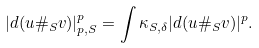Convert formula to latex. <formula><loc_0><loc_0><loc_500><loc_500>| d ( u \# _ { S } v ) | ^ { p } _ { p , S } = \int \kappa _ { S , \delta } | d ( u \# _ { S } v ) | ^ { p } .</formula> 